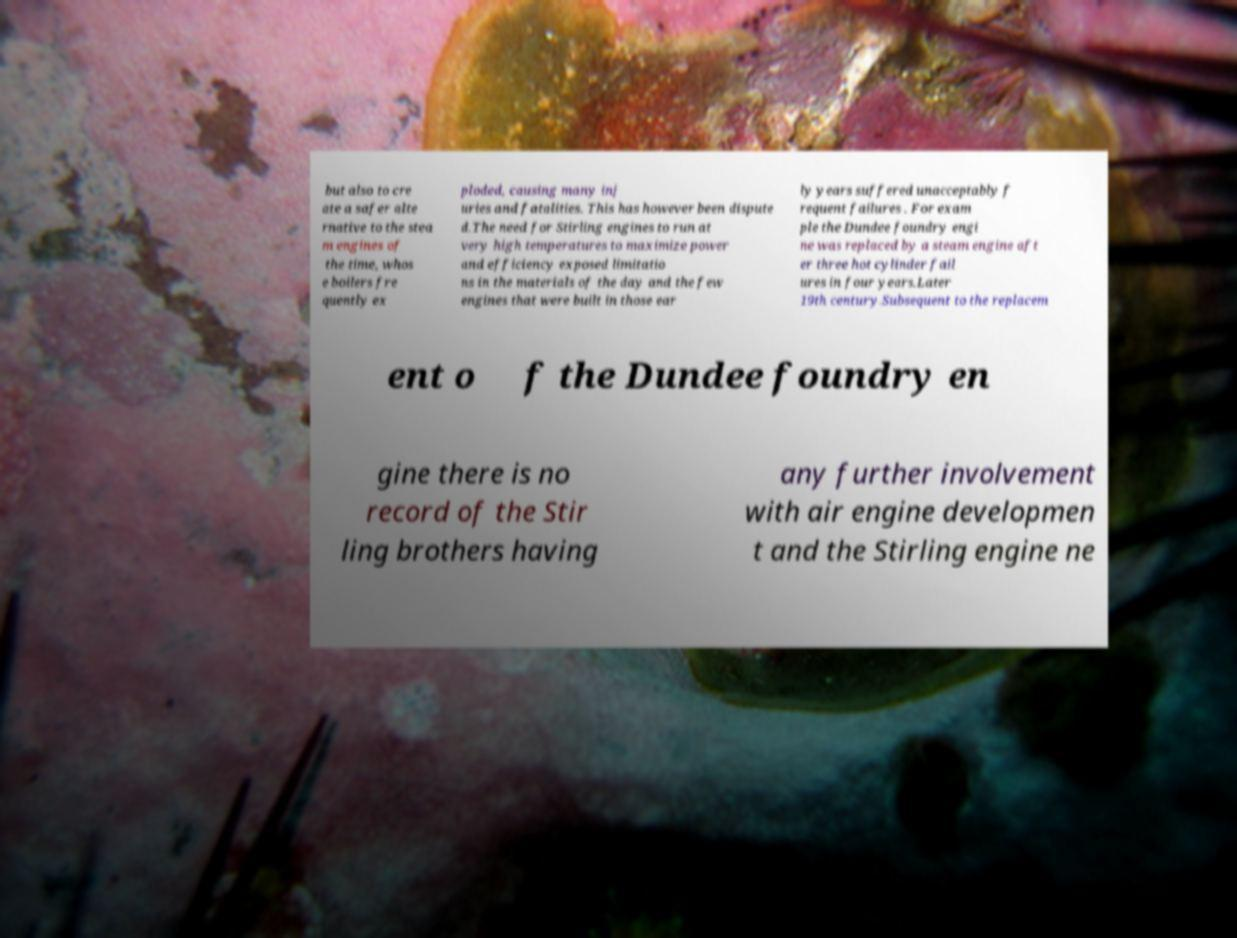Could you extract and type out the text from this image? but also to cre ate a safer alte rnative to the stea m engines of the time, whos e boilers fre quently ex ploded, causing many inj uries and fatalities. This has however been dispute d.The need for Stirling engines to run at very high temperatures to maximize power and efficiency exposed limitatio ns in the materials of the day and the few engines that were built in those ear ly years suffered unacceptably f requent failures . For exam ple the Dundee foundry engi ne was replaced by a steam engine aft er three hot cylinder fail ures in four years.Later 19th century.Subsequent to the replacem ent o f the Dundee foundry en gine there is no record of the Stir ling brothers having any further involvement with air engine developmen t and the Stirling engine ne 